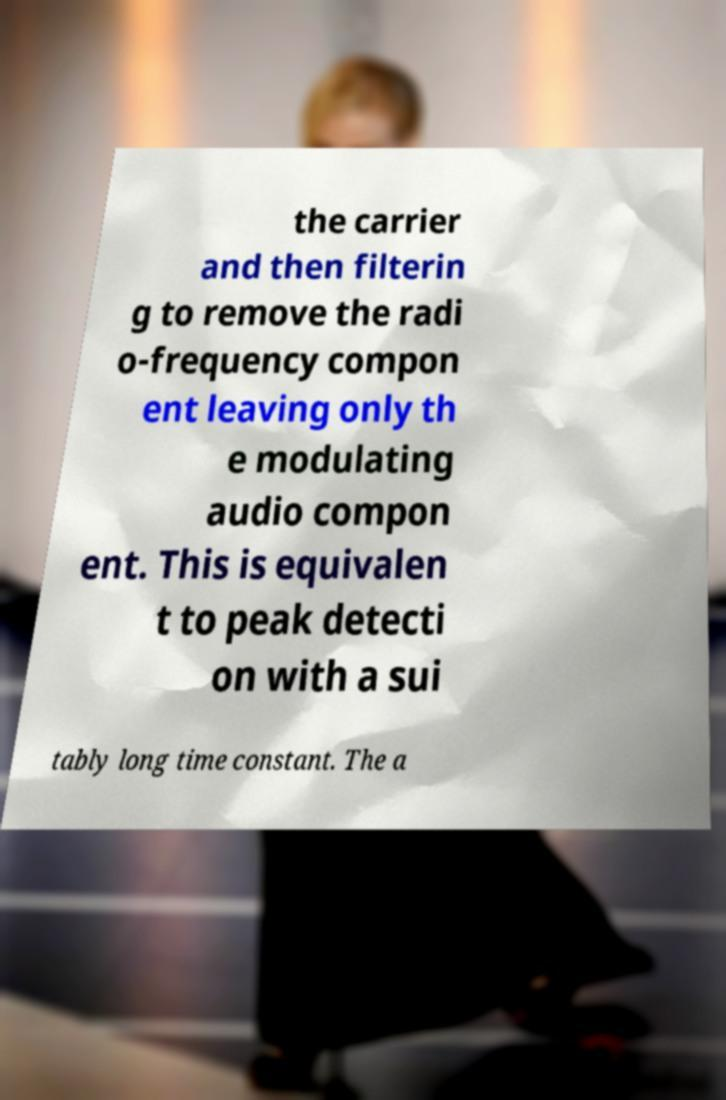I need the written content from this picture converted into text. Can you do that? the carrier and then filterin g to remove the radi o-frequency compon ent leaving only th e modulating audio compon ent. This is equivalen t to peak detecti on with a sui tably long time constant. The a 